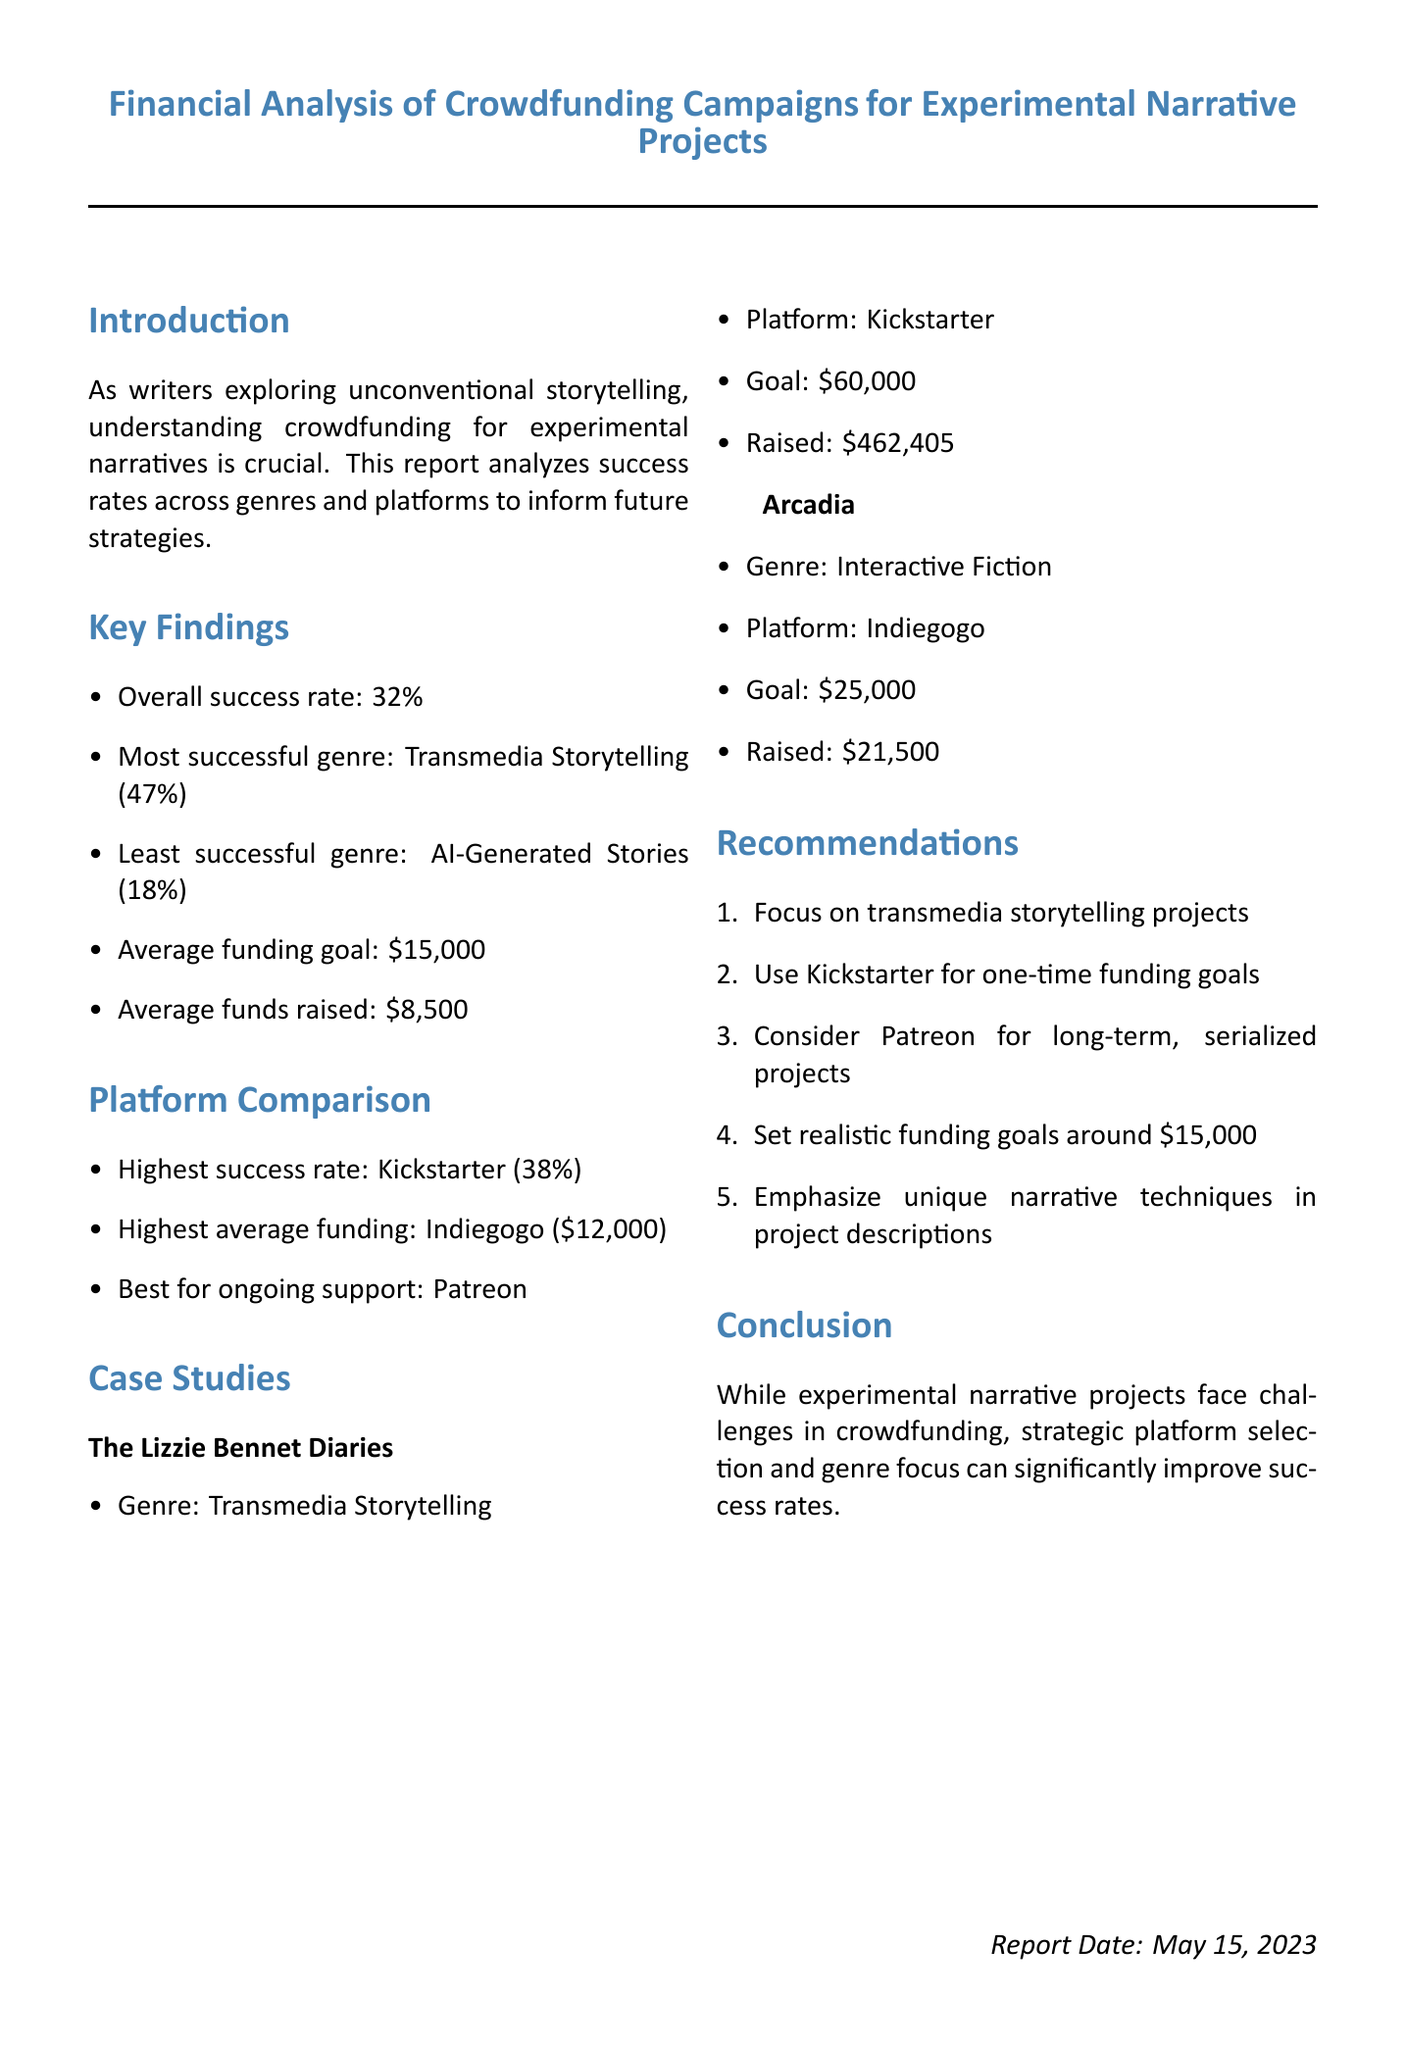What is the overall success rate of crowdfunding campaigns? The overall success rate is provided in the key findings section of the report.
Answer: 32% Which genre had the least success rate? The report specifies the least successful genre in the key findings.
Answer: AI-Generated Stories What platform has the highest success rate? The platform comparison section indicates which platform has the highest rate of success.
Answer: Kickstarter What was the goal amount for "The Lizzie Bennet Diaries"? The document lists the goal for this specific project in the case studies section.
Answer: $60,000 What is the average funding goal across all analyzed campaigns? The average funding goal is directly stated in the key findings.
Answer: $15,000 Which project raised the most funds? This information is specified in the case studies section comparing individual projects.
Answer: The Lizzie Bennet Diaries What genre should writers focus on for higher success rates? The recommendations section mentions a genre that is more likely to succeed in crowdfunding.
Answer: Transmedia Storytelling What is the best platform for ongoing support? The platform comparison section identifies the most suitable platform for this purpose.
Answer: Patreon 